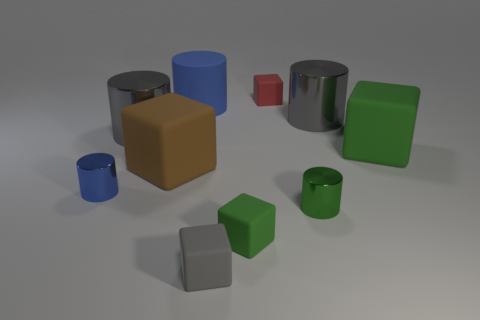There is a green rubber object to the right of the tiny red object; is its shape the same as the tiny object behind the blue matte cylinder? yes 